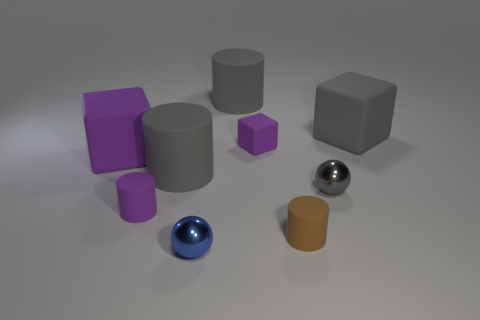There is a ball left of the big object behind the gray thing right of the gray shiny sphere; what is it made of?
Provide a short and direct response. Metal. What shape is the brown matte object that is the same size as the gray ball?
Offer a terse response. Cylinder. Are there fewer purple matte cylinders than big green rubber cylinders?
Your answer should be compact. No. What number of blue balls have the same size as the blue metal thing?
Give a very brief answer. 0. What is the shape of the small rubber thing that is the same color as the small block?
Ensure brevity in your answer.  Cylinder. What is the big purple thing made of?
Your response must be concise. Rubber. What is the size of the gray rubber cylinder behind the large purple thing?
Give a very brief answer. Large. What number of brown rubber objects have the same shape as the gray metal object?
Provide a succinct answer. 0. The gray thing that is the same material as the small blue ball is what shape?
Provide a succinct answer. Sphere. What number of purple things are either large rubber cylinders or tiny metallic spheres?
Give a very brief answer. 0. 